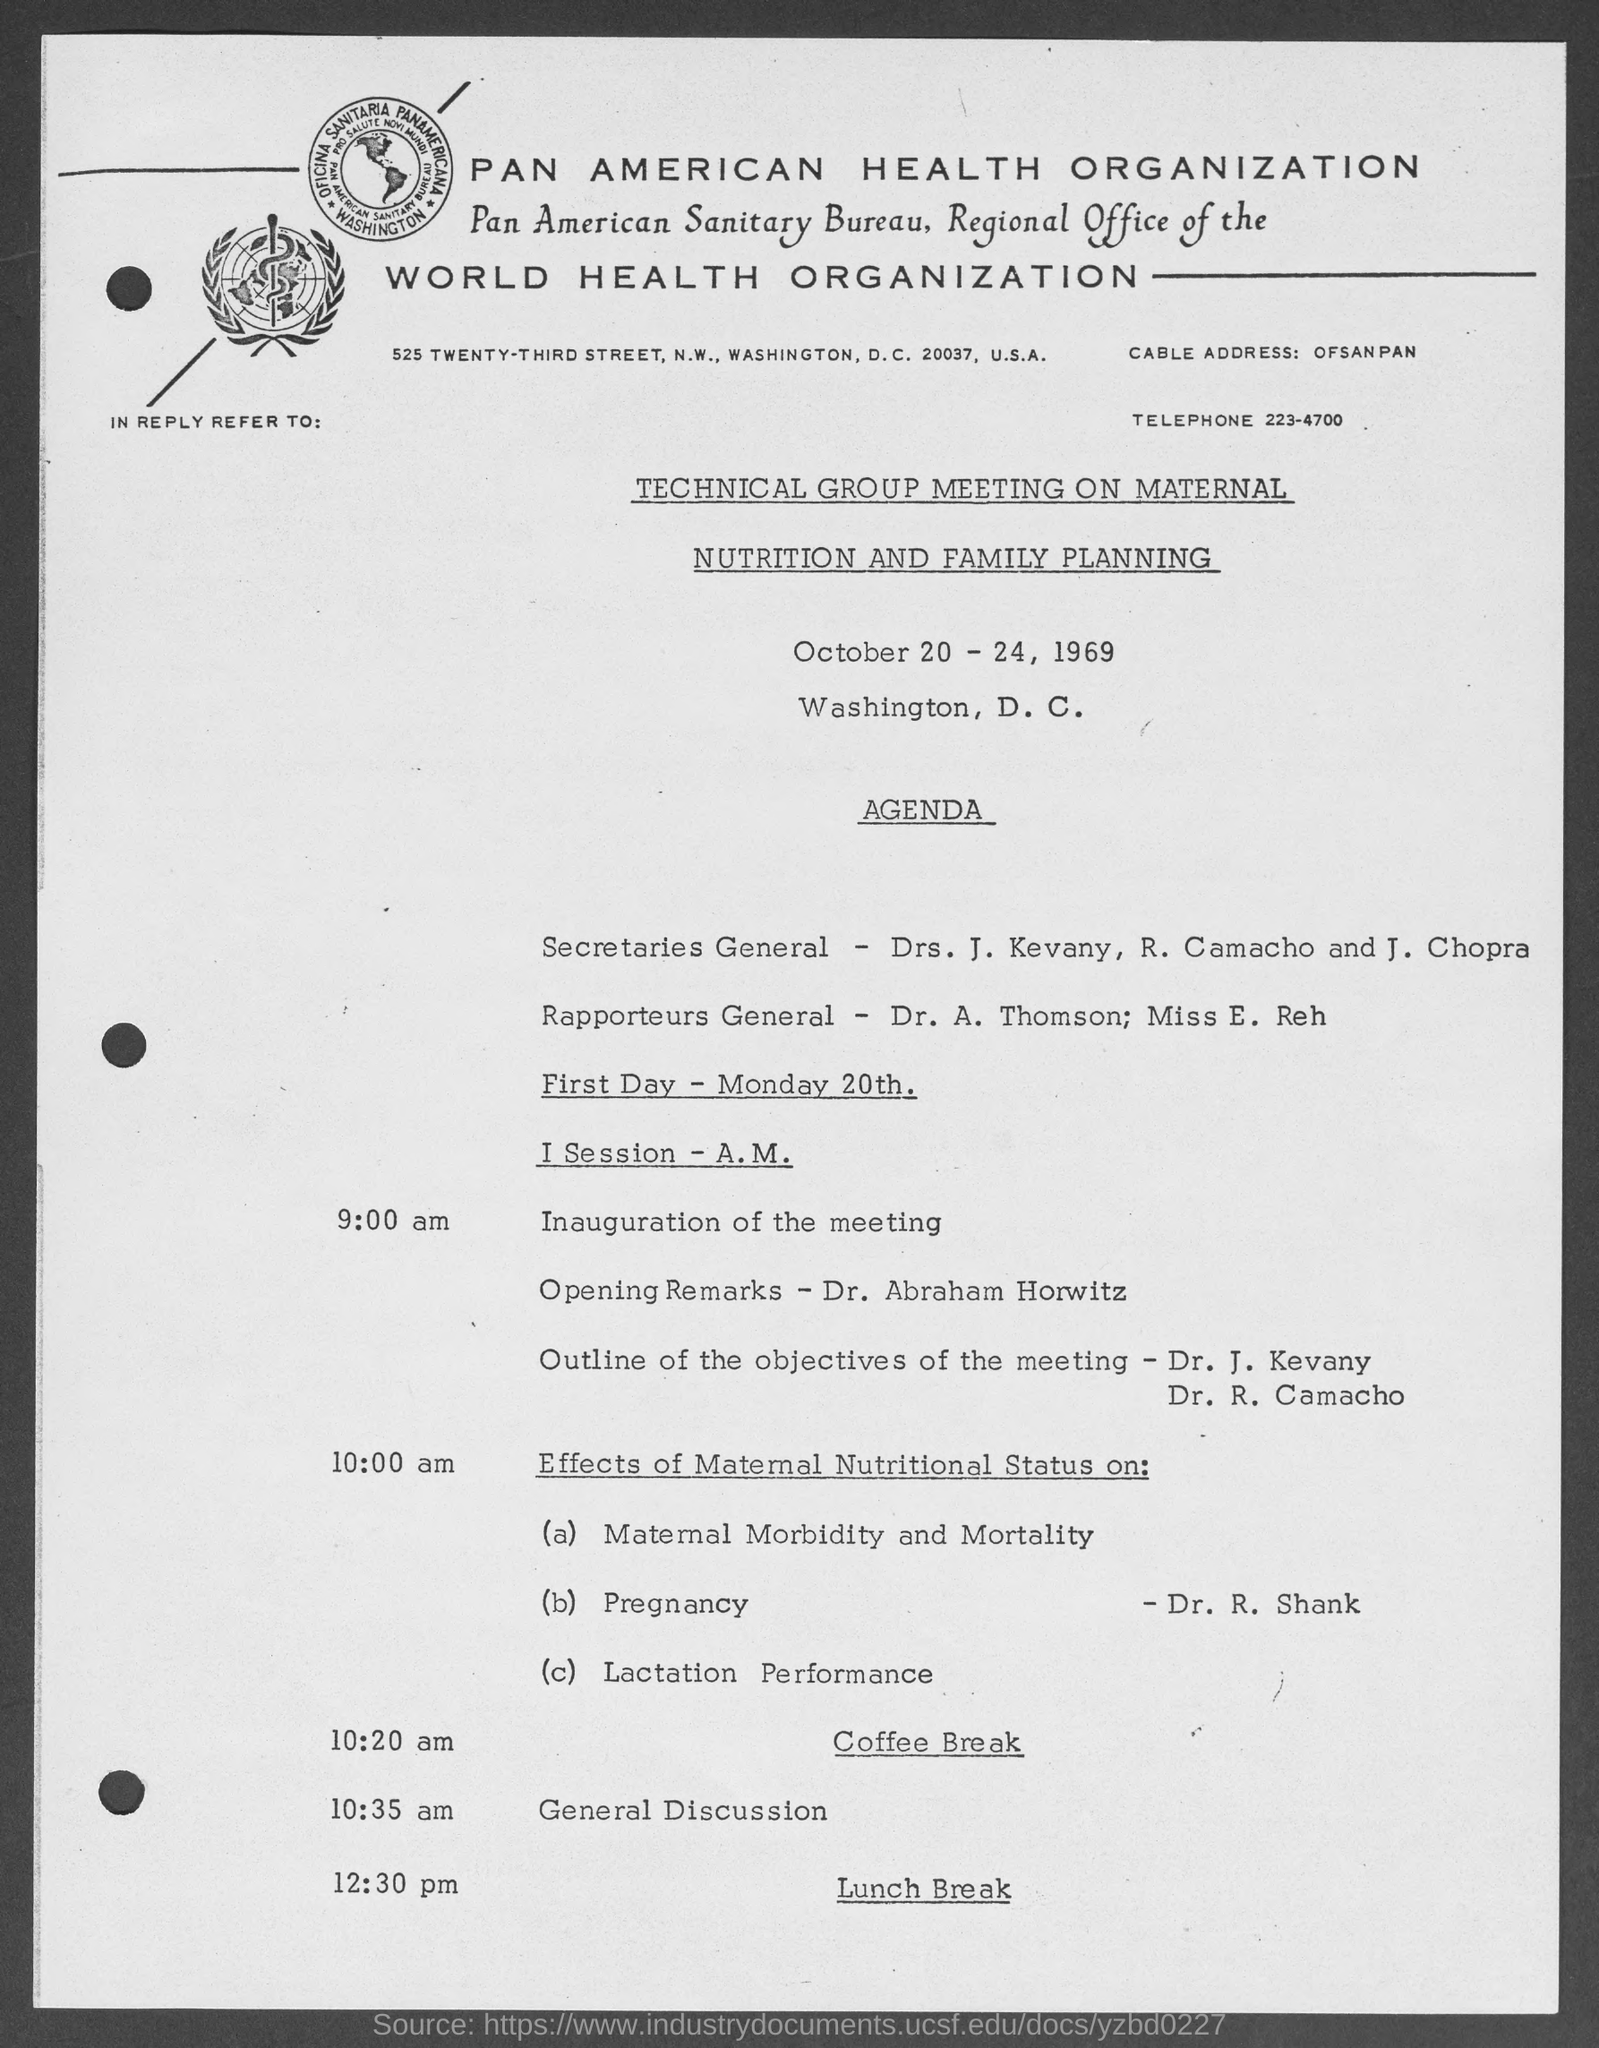What is the telephone number given?
Give a very brief answer. 223-4700. Who are the Rapporteurs General?
Make the answer very short. Dr. A. Thomson; Miss E. Reh. Who will give the opening remarks on First day- Monday 20th?
Provide a short and direct response. Dr. Abraham Horwitz. 